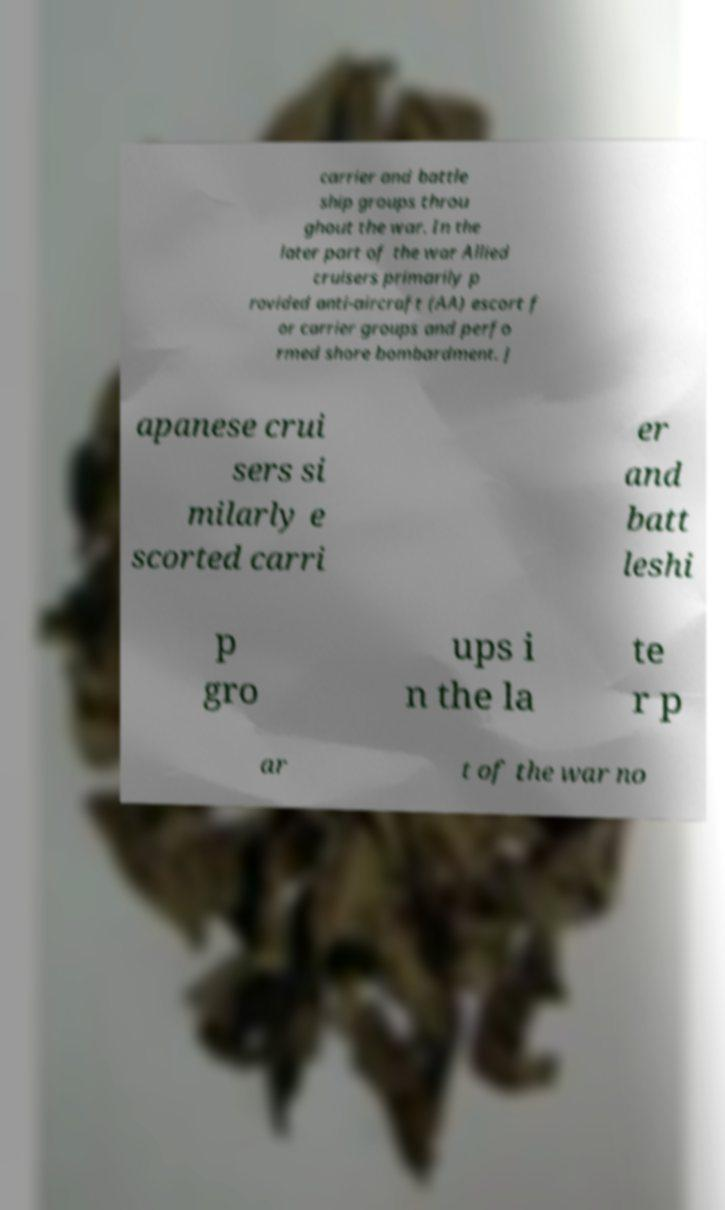What messages or text are displayed in this image? I need them in a readable, typed format. carrier and battle ship groups throu ghout the war. In the later part of the war Allied cruisers primarily p rovided anti-aircraft (AA) escort f or carrier groups and perfo rmed shore bombardment. J apanese crui sers si milarly e scorted carri er and batt leshi p gro ups i n the la te r p ar t of the war no 